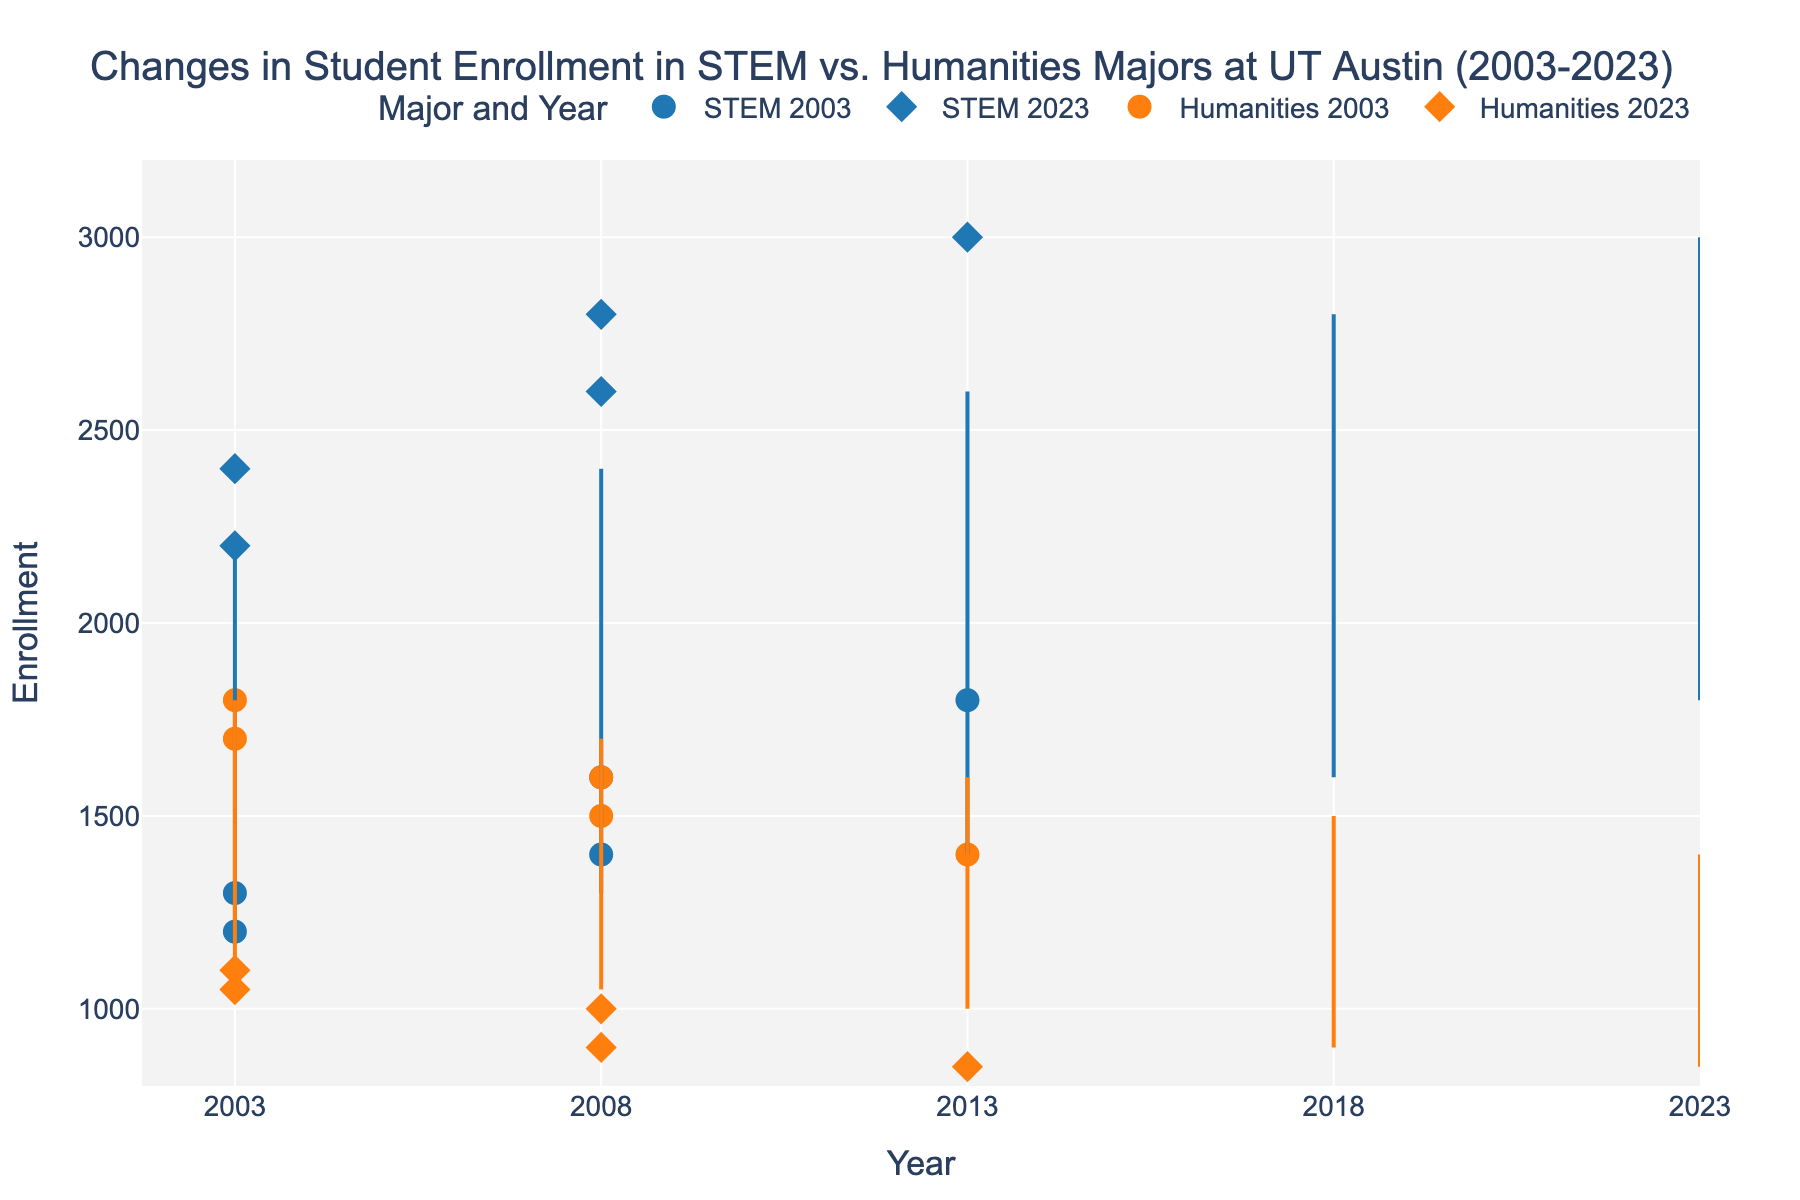What's the title of the plot? The title of the plot is indicated at the top and provides context for what the figure represents. It helps the viewer understand the focus of the data presented.
Answer: Changes in Student Enrollment in STEM vs. Humanities Majors at UT Austin (2003-2023) What are the x-axis and y-axis titles? The x-axis title is located at the bottom of the graph, and it indicates the variable along the horizontal plane. The y-axis title is found along the left side of the graph, indicating the variable along the vertical plane.
Answer: x-axis: Year, y-axis: Enrollment How has STEM enrollment changed from 2003 to 2023? By examining the markers and their connecting lines for STEM at the beginning and end years, we see a blue circle for 2003 and a blue diamond for 2023. STEM enrollment increased over time, as indicated by the higher position of the blue diamond compared to the blue circle.
Answer: Increased What was the Humanities enrollment in 2003 compared to 2023? Look at the orange markers on the graph for the years 2003 and 2023. The orange circle for 2003 is higher on the y-axis than the orange diamond for 2023, indicating a decrease in enrollment.
Answer: Decreased What is the largest increase in STEM enrollment between two consecutive years shown? Compare the blue circles and diamonds between consecutive years. The biggest vertical gap represents the largest increase. Between 2003 (1200) and 2023 (3000), the enrollment increased by 1800.
Answer: 1200 to 3000 What is the trend in Humanities enrollment over the 20 years? Observing the positions of the orange markers and the lines connecting them over time reveals a downward trend, as the markers move lower on the y-axis from 2003 to 2023.
Answer: Decreasing Which major saw a greater change in enrollment over the 20 years? Calculate the difference in enrollment from 2003 to 2023 for both majors: STEM (3000 - 1200 = 1800) and Humanities (850 - 1800 = -950). STEM saw a greater change.
Answer: STEM How does the difference in enrollment between STEM and Humanities in 2023 compare to that in 2003? Compare the enrollment numbers for both majors in the specified years. In 2003: STEM (1200), Humanities (1800), difference = 600. In 2023: STEM (3000), Humanities (850), difference = 2150. The differences are 600 in 2003 and 2150 in 2023, indicating the gap increased over time.
Answer: Increased What can we infer from the dumbbell lines connecting the markers for each year? Dumbbell lines indicate the change over time for each major and the shift in enrollment figures. Steeper lines suggest more significant changes, while flatter lines indicate less change. By looking at the slope of the lines, especially the lines in blue and orange, we infer that STEM enrollment generally increased while Humanities enrollment decreased.
Answer: STEM increases, Humanities decreases 